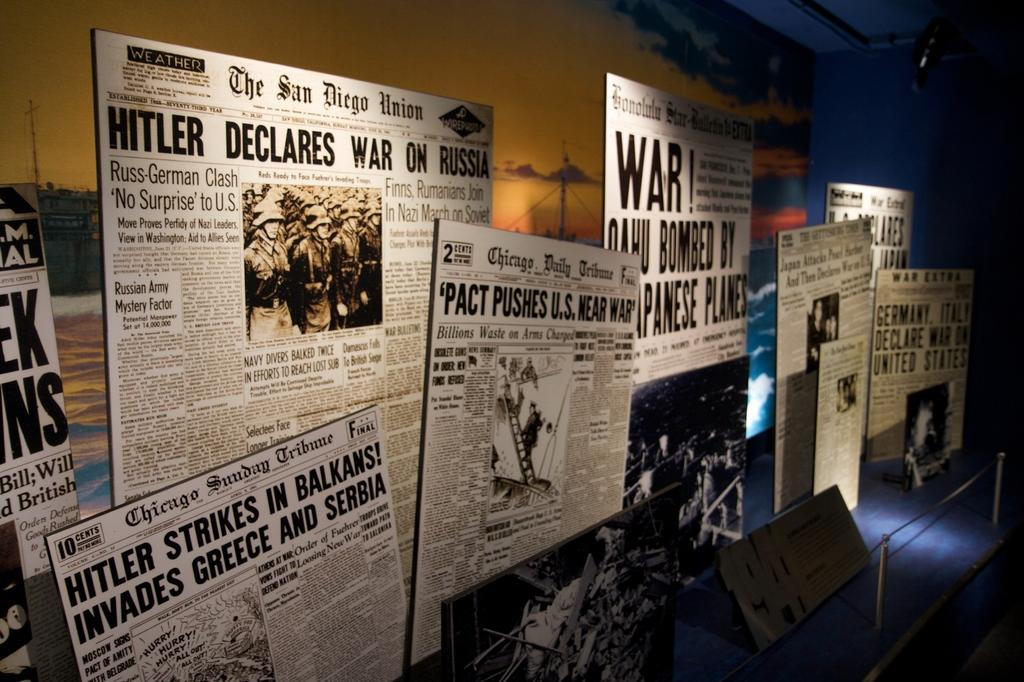<image>
Relay a brief, clear account of the picture shown. Many newspaper articles on a wall including one that says "Pact Pushes U.S.". 